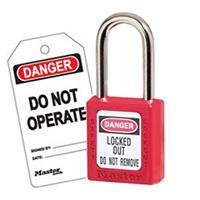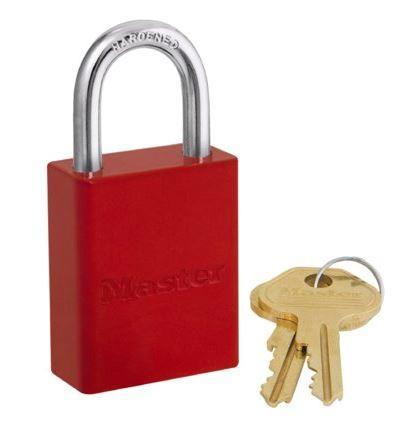The first image is the image on the left, the second image is the image on the right. Evaluate the accuracy of this statement regarding the images: "Each image shows a red padlock, and in one image there is also one or more keys visible". Is it true? Answer yes or no. Yes. The first image is the image on the left, the second image is the image on the right. For the images displayed, is the sentence "Each image includes just one lock, and all locks have red bodies." factually correct? Answer yes or no. Yes. 